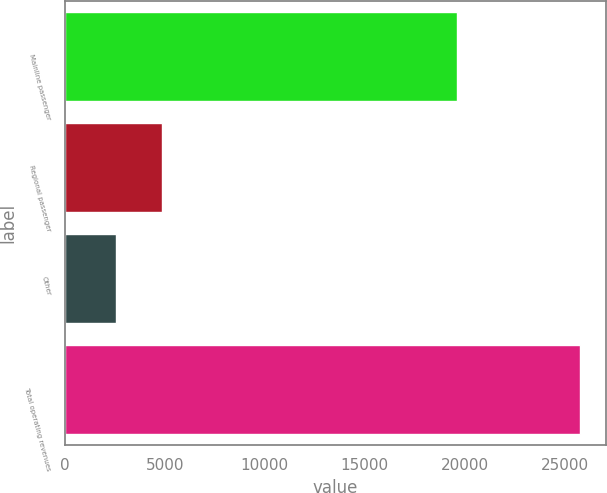Convert chart to OTSL. <chart><loc_0><loc_0><loc_500><loc_500><bar_chart><fcel>Mainline passenger<fcel>Regional passenger<fcel>Other<fcel>Total operating revenues<nl><fcel>19594<fcel>4882.7<fcel>2563<fcel>25760<nl></chart> 